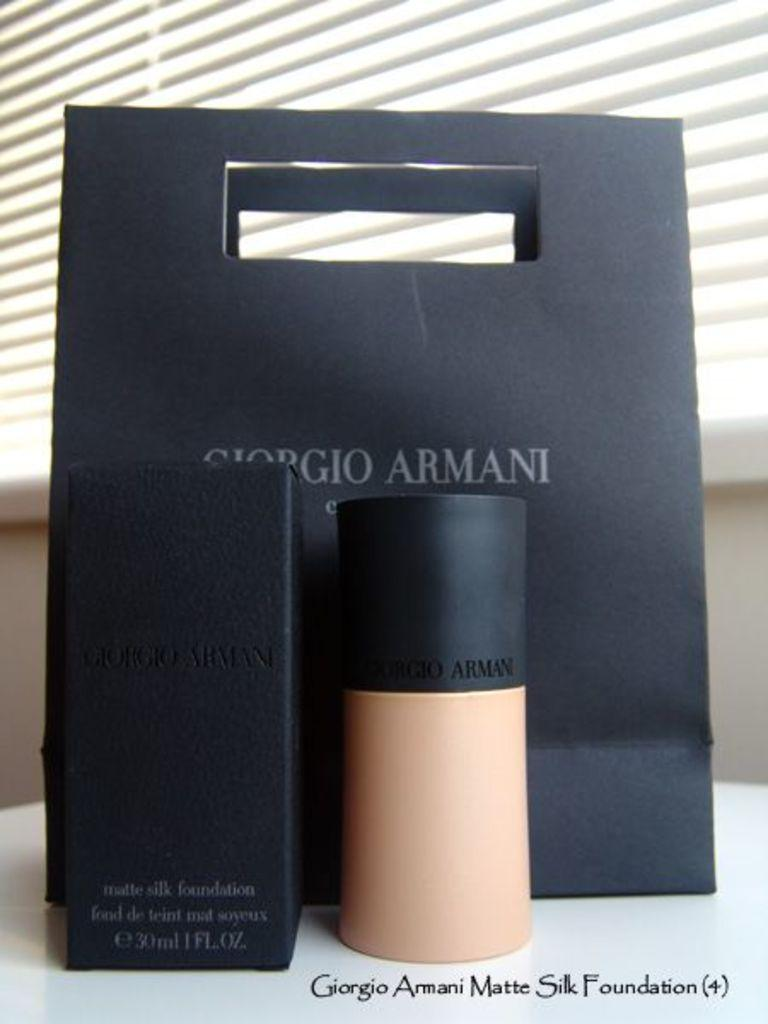<image>
Write a terse but informative summary of the picture. A bottle of Girogio Armani foundation with a box and bag. 